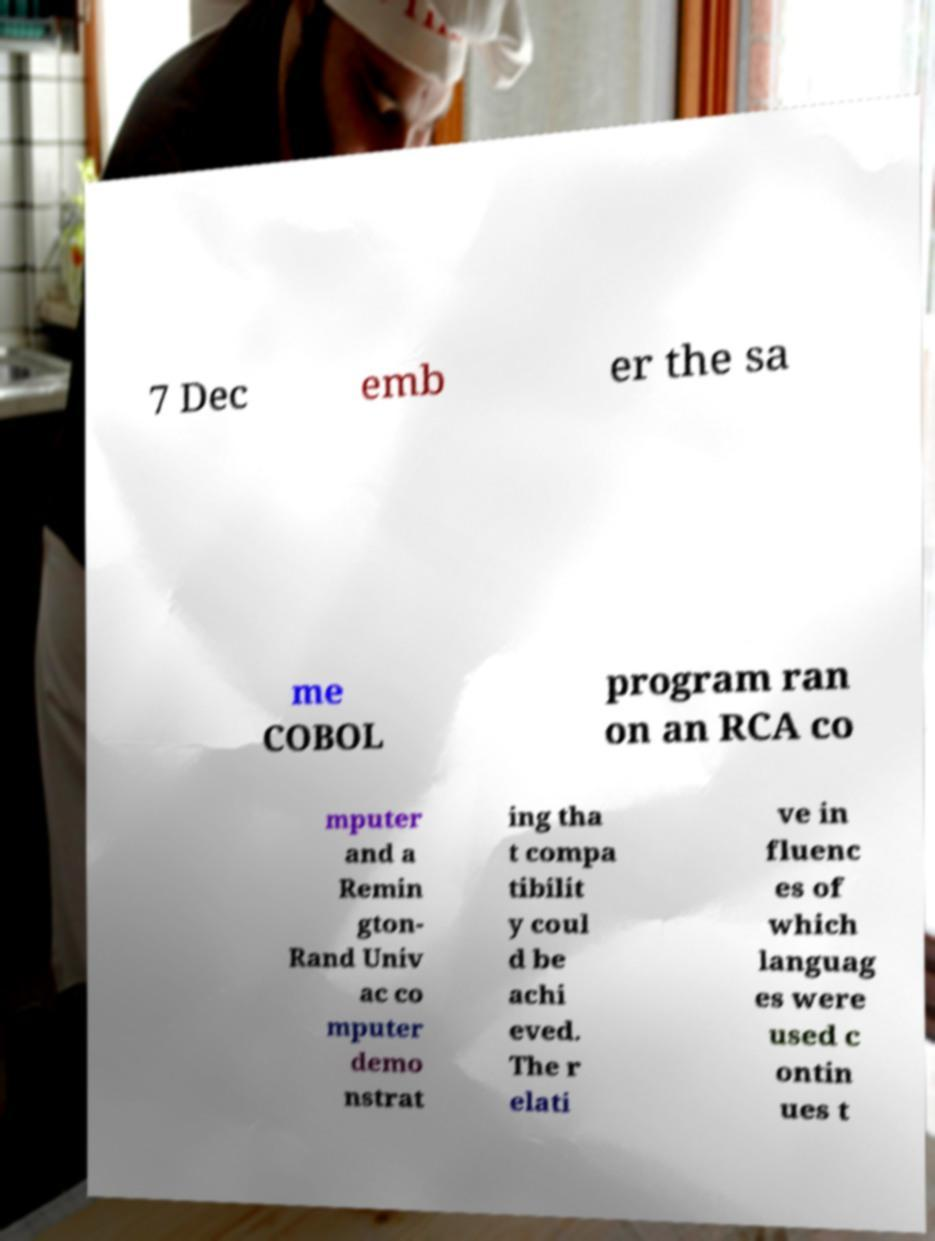Can you accurately transcribe the text from the provided image for me? 7 Dec emb er the sa me COBOL program ran on an RCA co mputer and a Remin gton- Rand Univ ac co mputer demo nstrat ing tha t compa tibilit y coul d be achi eved. The r elati ve in fluenc es of which languag es were used c ontin ues t 